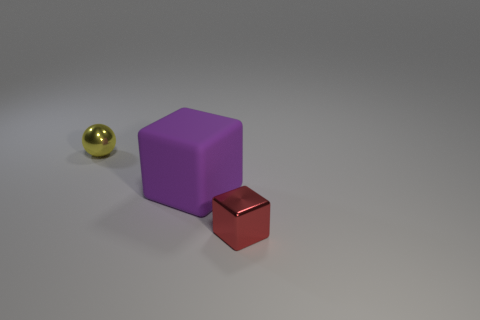Add 2 metal cylinders. How many objects exist? 5 Subtract all spheres. How many objects are left? 2 Subtract 0 green cylinders. How many objects are left? 3 Subtract all red metallic objects. Subtract all small purple balls. How many objects are left? 2 Add 1 tiny yellow metal spheres. How many tiny yellow metal spheres are left? 2 Add 1 spheres. How many spheres exist? 2 